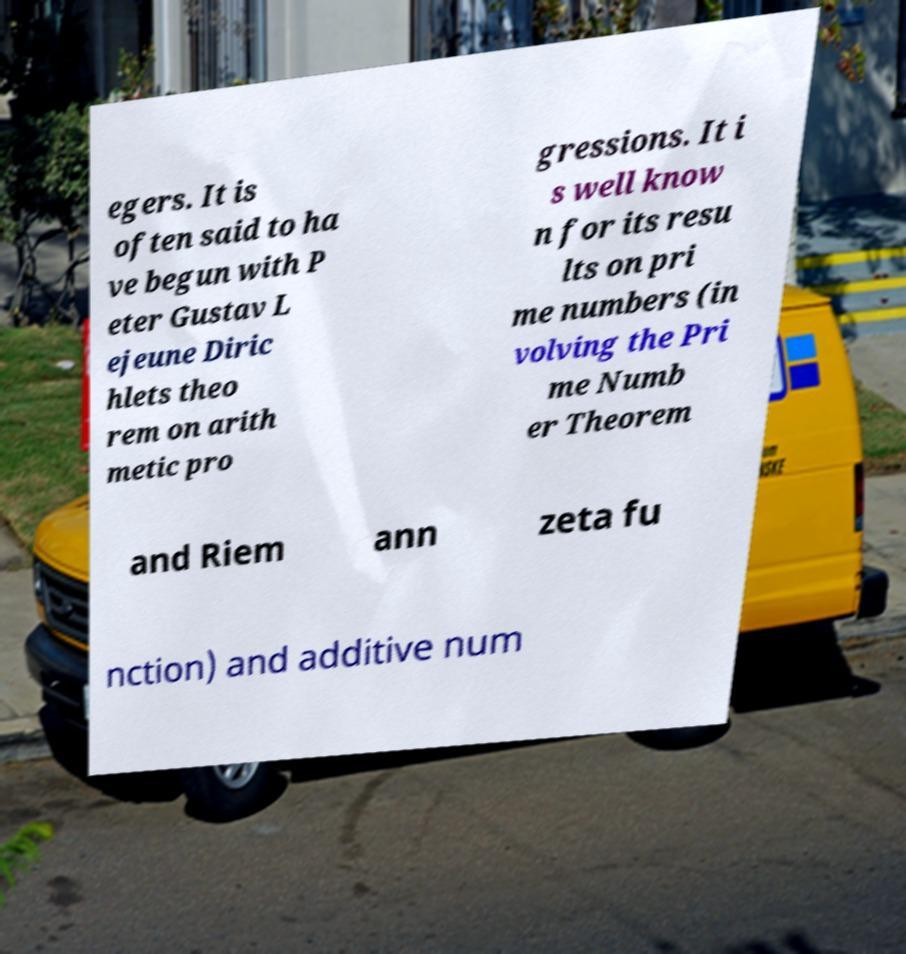There's text embedded in this image that I need extracted. Can you transcribe it verbatim? egers. It is often said to ha ve begun with P eter Gustav L ejeune Diric hlets theo rem on arith metic pro gressions. It i s well know n for its resu lts on pri me numbers (in volving the Pri me Numb er Theorem and Riem ann zeta fu nction) and additive num 